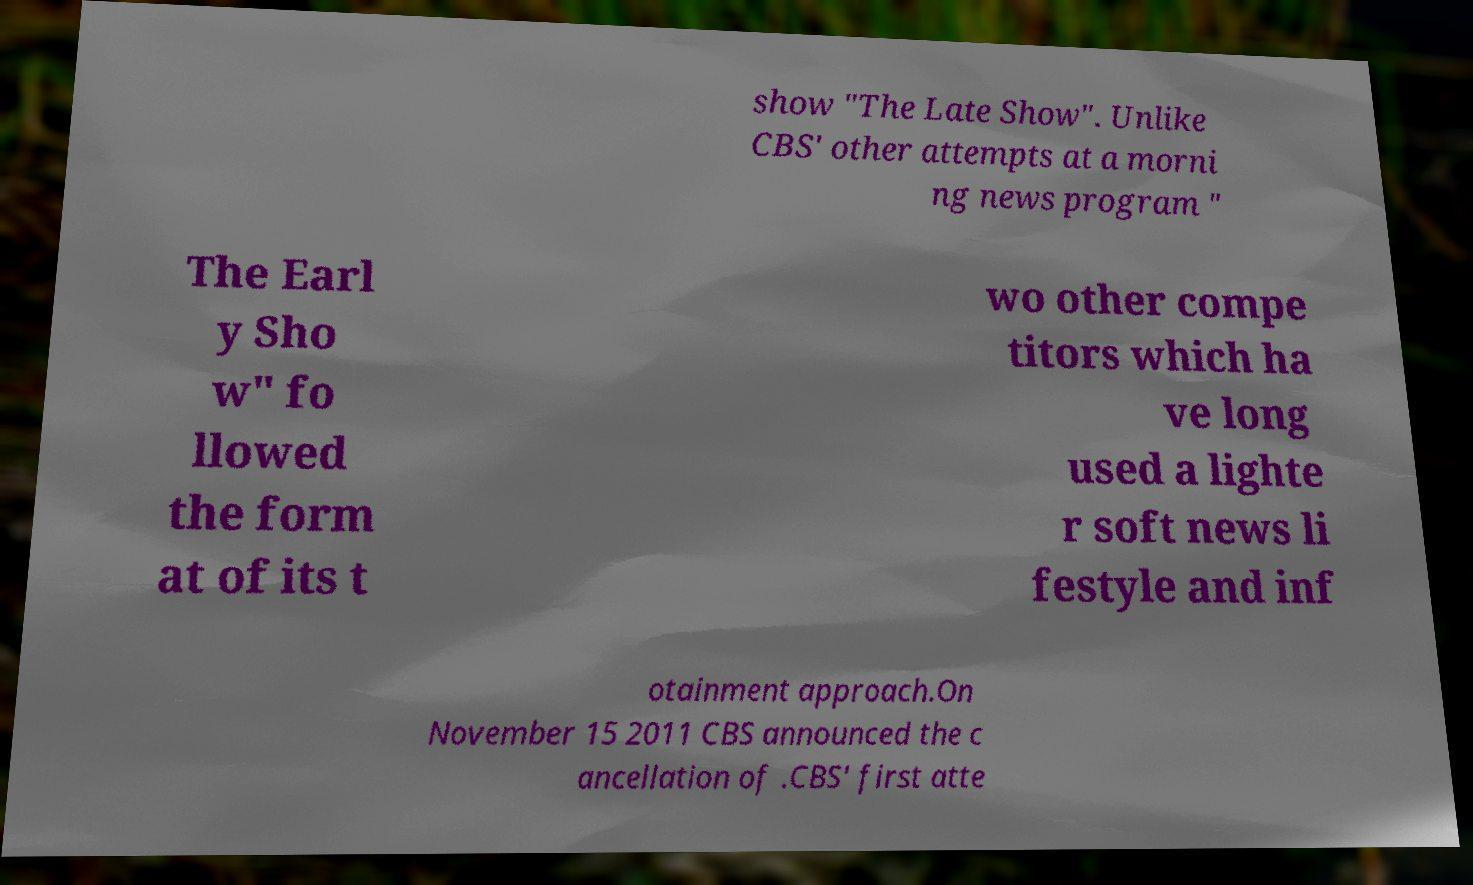Please identify and transcribe the text found in this image. show "The Late Show". Unlike CBS' other attempts at a morni ng news program " The Earl y Sho w" fo llowed the form at of its t wo other compe titors which ha ve long used a lighte r soft news li festyle and inf otainment approach.On November 15 2011 CBS announced the c ancellation of .CBS' first atte 